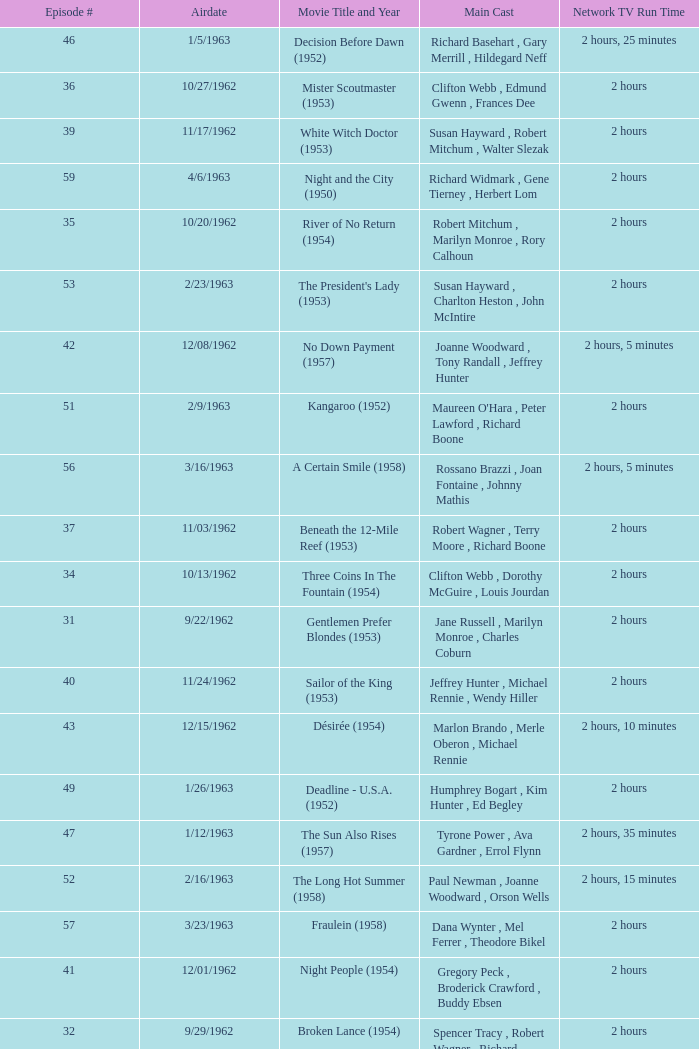How many runtimes does episode 53 have? 1.0. 